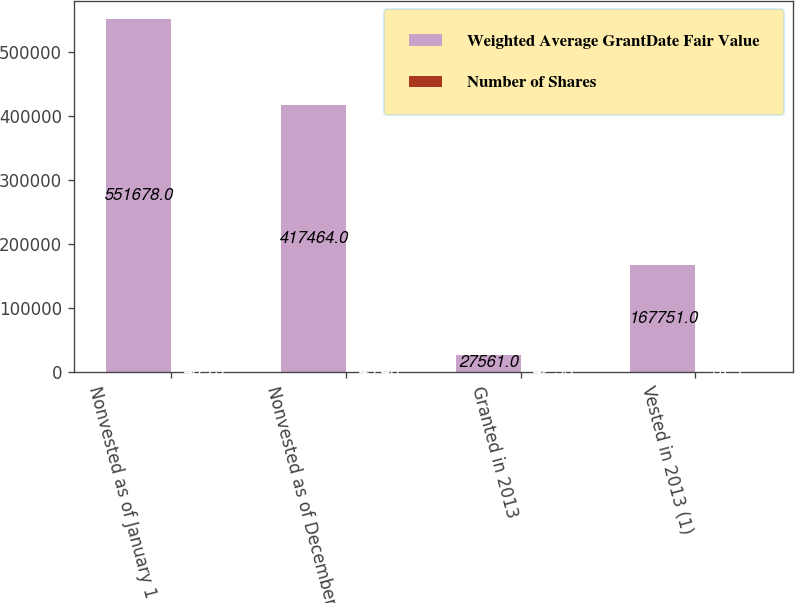Convert chart. <chart><loc_0><loc_0><loc_500><loc_500><stacked_bar_chart><ecel><fcel>Nonvested as of January 1 2013<fcel>Nonvested as of December 31<fcel>Granted in 2013<fcel>Vested in 2013 (1)<nl><fcel>Weighted Average GrantDate Fair Value<fcel>551678<fcel>417464<fcel>27561<fcel>167751<nl><fcel>Number of Shares<fcel>46.73<fcel>45.46<fcel>42.53<fcel>37.1<nl></chart> 